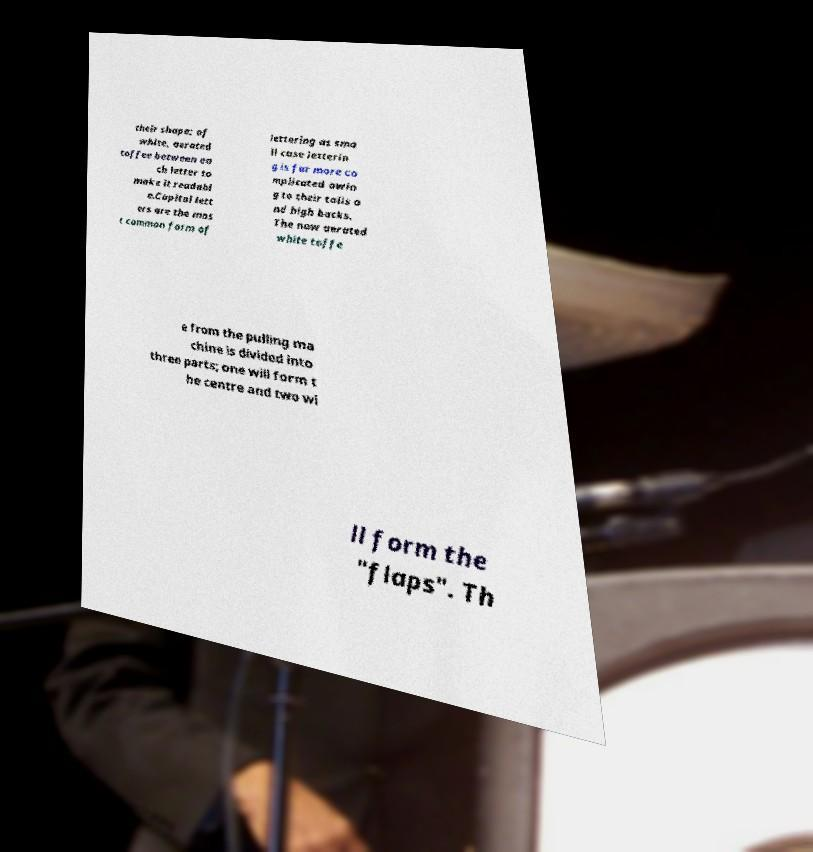Please identify and transcribe the text found in this image. their shape; of white, aerated toffee between ea ch letter to make it readabl e.Capital lett ers are the mos t common form of lettering as sma ll case letterin g is far more co mplicated owin g to their tails a nd high backs. The now aerated white toffe e from the pulling ma chine is divided into three parts; one will form t he centre and two wi ll form the "flaps". Th 